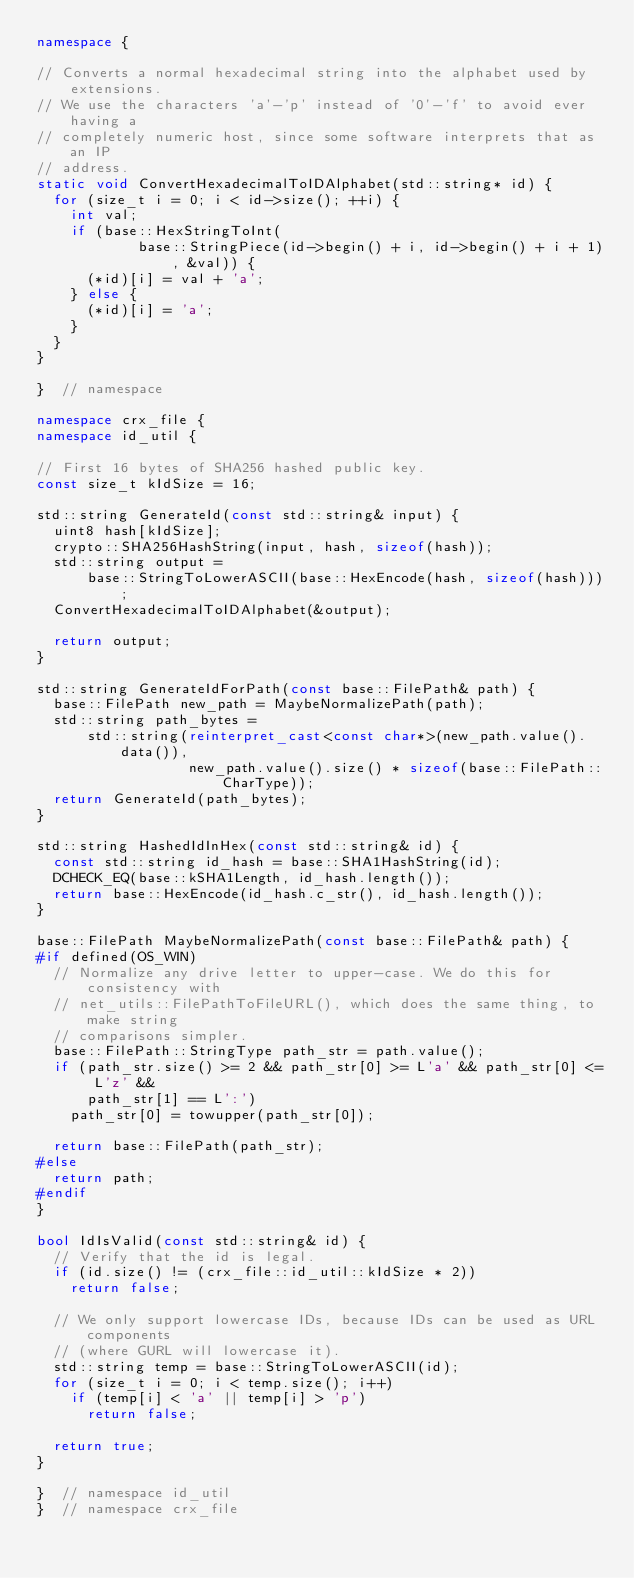Convert code to text. <code><loc_0><loc_0><loc_500><loc_500><_C++_>namespace {

// Converts a normal hexadecimal string into the alphabet used by extensions.
// We use the characters 'a'-'p' instead of '0'-'f' to avoid ever having a
// completely numeric host, since some software interprets that as an IP
// address.
static void ConvertHexadecimalToIDAlphabet(std::string* id) {
  for (size_t i = 0; i < id->size(); ++i) {
    int val;
    if (base::HexStringToInt(
            base::StringPiece(id->begin() + i, id->begin() + i + 1), &val)) {
      (*id)[i] = val + 'a';
    } else {
      (*id)[i] = 'a';
    }
  }
}

}  // namespace

namespace crx_file {
namespace id_util {

// First 16 bytes of SHA256 hashed public key.
const size_t kIdSize = 16;

std::string GenerateId(const std::string& input) {
  uint8 hash[kIdSize];
  crypto::SHA256HashString(input, hash, sizeof(hash));
  std::string output =
      base::StringToLowerASCII(base::HexEncode(hash, sizeof(hash)));
  ConvertHexadecimalToIDAlphabet(&output);

  return output;
}

std::string GenerateIdForPath(const base::FilePath& path) {
  base::FilePath new_path = MaybeNormalizePath(path);
  std::string path_bytes =
      std::string(reinterpret_cast<const char*>(new_path.value().data()),
                  new_path.value().size() * sizeof(base::FilePath::CharType));
  return GenerateId(path_bytes);
}

std::string HashedIdInHex(const std::string& id) {
  const std::string id_hash = base::SHA1HashString(id);
  DCHECK_EQ(base::kSHA1Length, id_hash.length());
  return base::HexEncode(id_hash.c_str(), id_hash.length());
}

base::FilePath MaybeNormalizePath(const base::FilePath& path) {
#if defined(OS_WIN)
  // Normalize any drive letter to upper-case. We do this for consistency with
  // net_utils::FilePathToFileURL(), which does the same thing, to make string
  // comparisons simpler.
  base::FilePath::StringType path_str = path.value();
  if (path_str.size() >= 2 && path_str[0] >= L'a' && path_str[0] <= L'z' &&
      path_str[1] == L':')
    path_str[0] = towupper(path_str[0]);

  return base::FilePath(path_str);
#else
  return path;
#endif
}

bool IdIsValid(const std::string& id) {
  // Verify that the id is legal.
  if (id.size() != (crx_file::id_util::kIdSize * 2))
    return false;

  // We only support lowercase IDs, because IDs can be used as URL components
  // (where GURL will lowercase it).
  std::string temp = base::StringToLowerASCII(id);
  for (size_t i = 0; i < temp.size(); i++)
    if (temp[i] < 'a' || temp[i] > 'p')
      return false;

  return true;
}

}  // namespace id_util
}  // namespace crx_file
</code> 